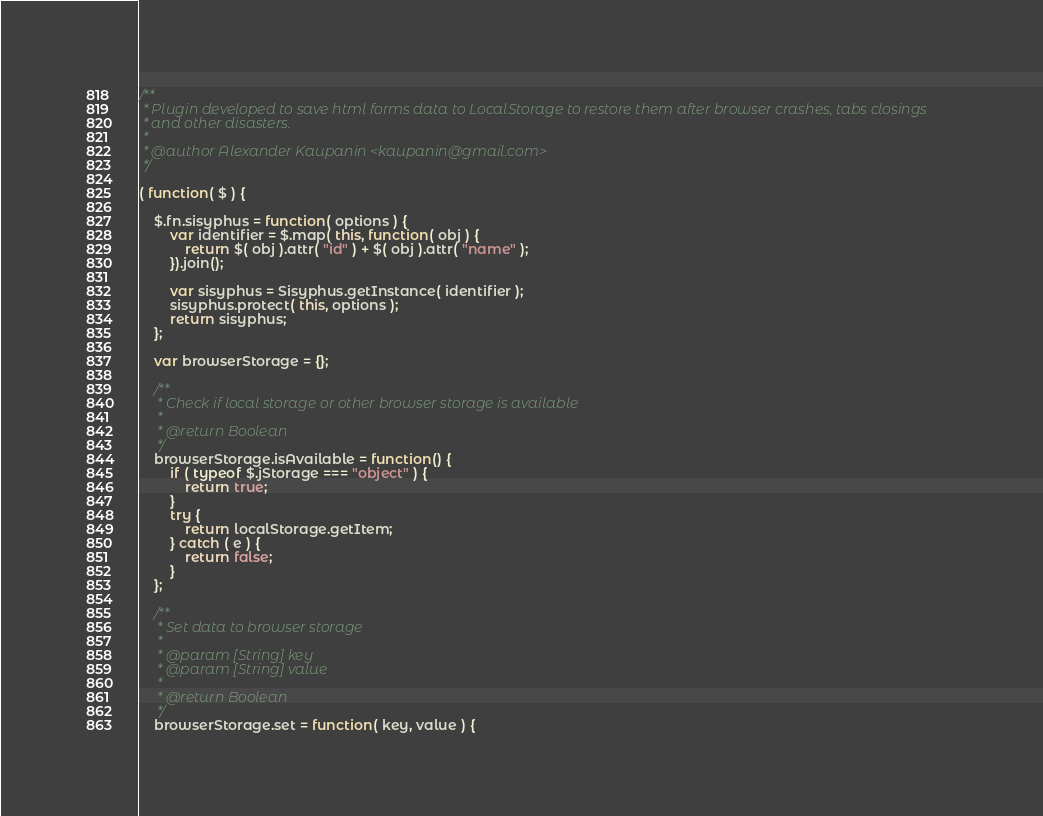Convert code to text. <code><loc_0><loc_0><loc_500><loc_500><_JavaScript_>/**
 * Plugin developed to save html forms data to LocalStorage to restore them after browser crashes, tabs closings
 * and other disasters.
 *
 * @author Alexander Kaupanin <kaupanin@gmail.com>
 */

( function( $ ) {

	$.fn.sisyphus = function( options ) {
		var identifier = $.map( this, function( obj ) {
			return $( obj ).attr( "id" ) + $( obj ).attr( "name" );
		}).join();

		var sisyphus = Sisyphus.getInstance( identifier );
		sisyphus.protect( this, options );
		return sisyphus;
	};

	var browserStorage = {};

	/**
	 * Check if local storage or other browser storage is available
	 *
	 * @return Boolean
	 */
	browserStorage.isAvailable = function() {
		if ( typeof $.jStorage === "object" ) {
			return true;
		}
		try {
			return localStorage.getItem;
		} catch ( e ) {
			return false;
		}
	};

	/**
	 * Set data to browser storage
	 *
	 * @param [String] key
	 * @param [String] value
	 *
	 * @return Boolean
	 */
	browserStorage.set = function( key, value ) {</code> 